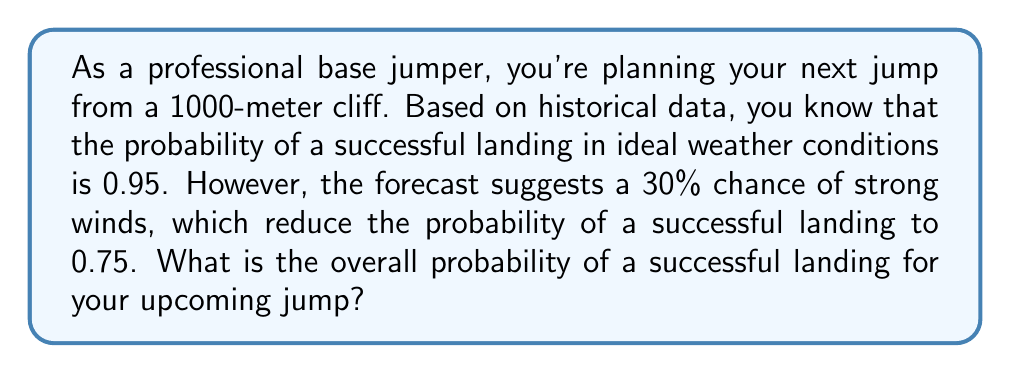Solve this math problem. To solve this problem, we'll use the law of total probability. Let's break it down step by step:

1) Define our events:
   S: Successful landing
   W: Strong winds occur
   N: Normal conditions (no strong winds)

2) Given probabilities:
   P(W) = 0.30 (30% chance of strong winds)
   P(N) = 1 - P(W) = 0.70 (70% chance of normal conditions)
   P(S|W) = 0.75 (probability of success given strong winds)
   P(S|N) = 0.95 (probability of success given normal conditions)

3) The law of total probability states:
   $$P(S) = P(S|W) \cdot P(W) + P(S|N) \cdot P(N)$$

4) Substituting our values:
   $$P(S) = 0.75 \cdot 0.30 + 0.95 \cdot 0.70$$

5) Calculating:
   $$P(S) = 0.225 + 0.665 = 0.89$$

Therefore, the overall probability of a successful landing is 0.89 or 89%.
Answer: 0.89 or 89% 